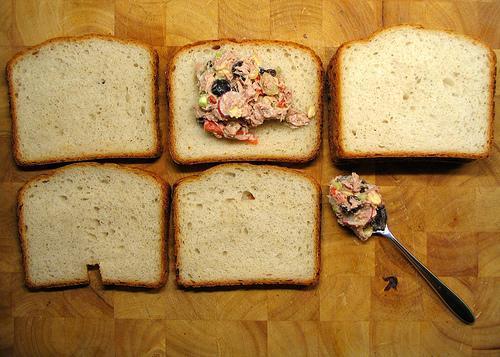How many pieces of bread are pictured?
Give a very brief answer. 5. How many people are in this picture?
Give a very brief answer. 0. How many spoons are in this picture?
Give a very brief answer. 1. 